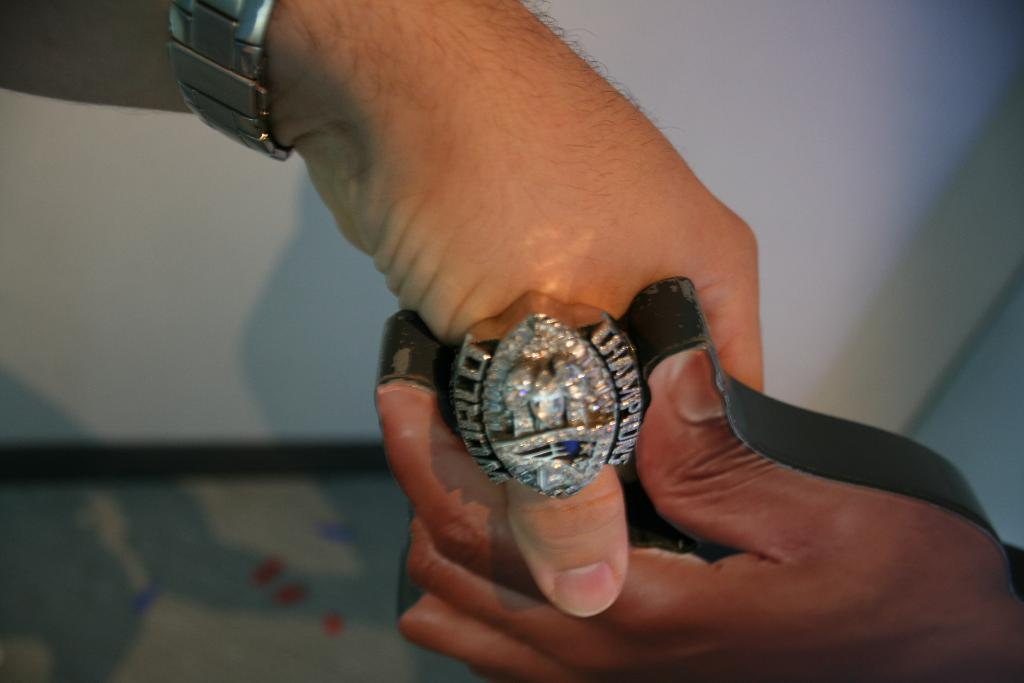<image>
Describe the image concisely. person wearing a World Champions ring with lots of diamonds in it. 